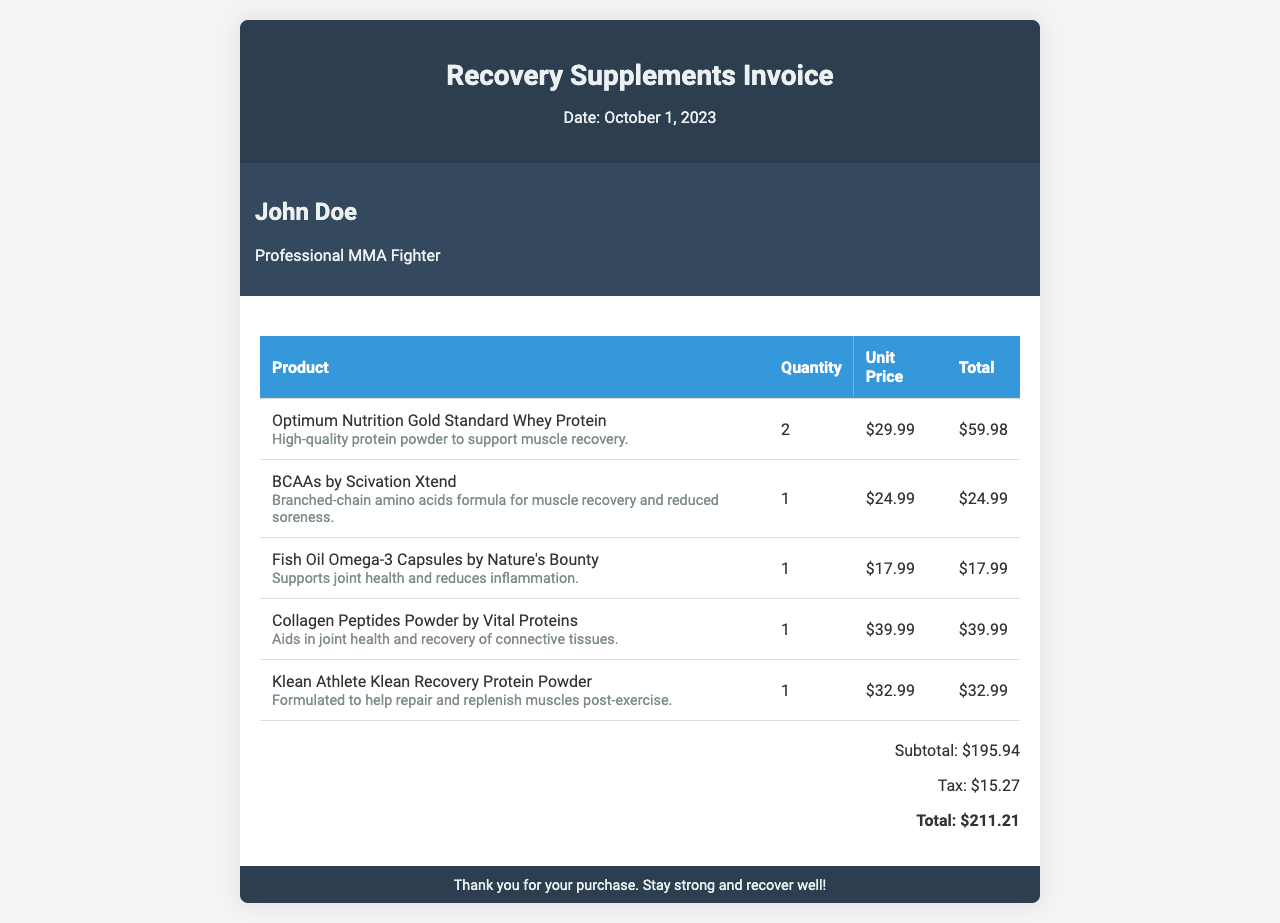What is the date of the invoice? The invoice date is stated at the top of the document.
Answer: October 1, 2023 Who is the customer listed on the invoice? The customer's name is mentioned in the customer info section of the document.
Answer: John Doe How many units of Optimum Nutrition Gold Standard Whey Protein were purchased? The quantity of this product is noted in the product table.
Answer: 2 What is the subtotal amount before tax? The subtotal is provided in the total section of the invoice.
Answer: $195.94 What is the tax amount calculated on the invoice? The tax amount is indicated in the total section of the document.
Answer: $15.27 What is the total cost of the invoice? The total cost is the final amount shown in the total section.
Answer: $211.21 Which product supports joint health and reduces inflammation? The product description provides specific benefits of the listed products.
Answer: Fish Oil Omega-3 Capsules by Nature's Bounty What is the unit price of BCAAs by Scivation Xtend? The unit price is listed in the table alongside the product details.
Answer: $24.99 How many different products are listed on the invoice? The number of separate products can be counted in the table of the document.
Answer: 5 